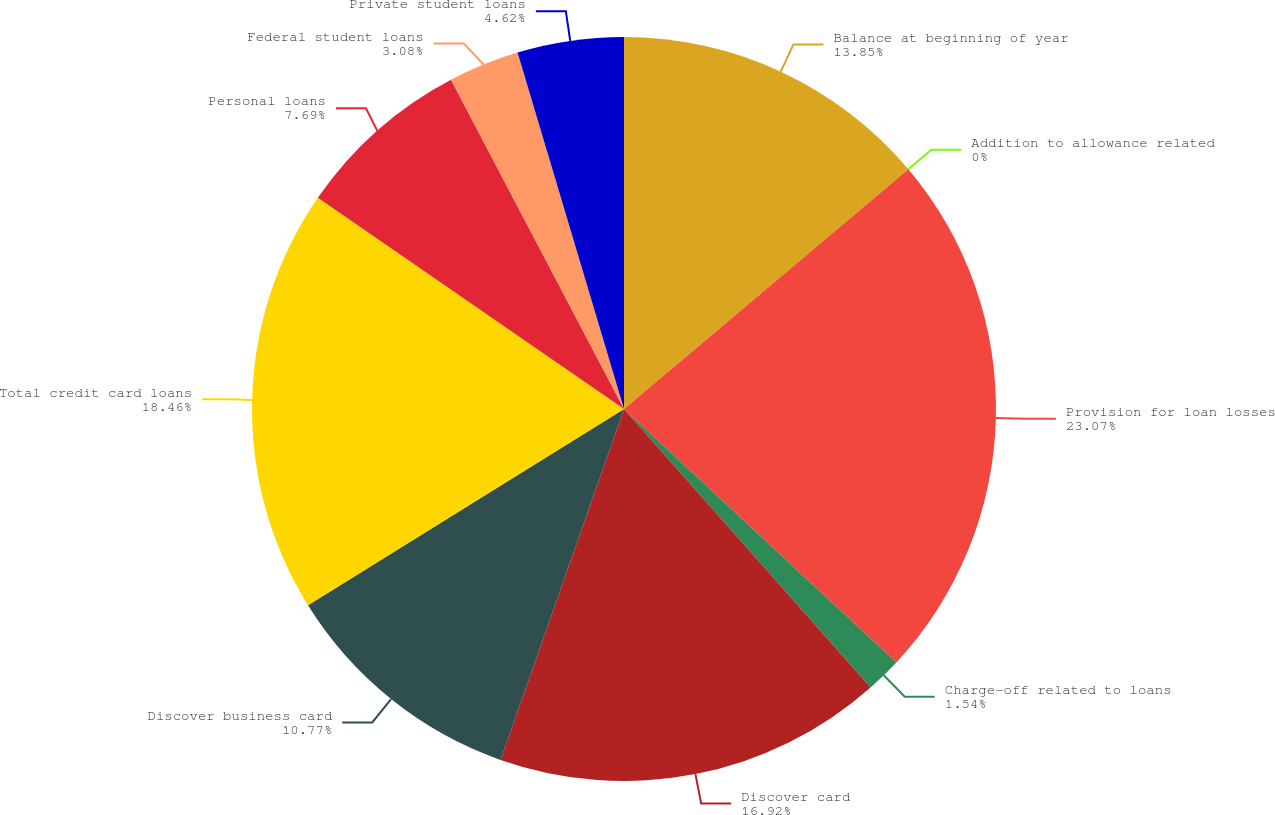Convert chart. <chart><loc_0><loc_0><loc_500><loc_500><pie_chart><fcel>Balance at beginning of year<fcel>Addition to allowance related<fcel>Provision for loan losses<fcel>Charge-off related to loans<fcel>Discover card<fcel>Discover business card<fcel>Total credit card loans<fcel>Personal loans<fcel>Federal student loans<fcel>Private student loans<nl><fcel>13.85%<fcel>0.0%<fcel>23.08%<fcel>1.54%<fcel>16.92%<fcel>10.77%<fcel>18.46%<fcel>7.69%<fcel>3.08%<fcel>4.62%<nl></chart> 